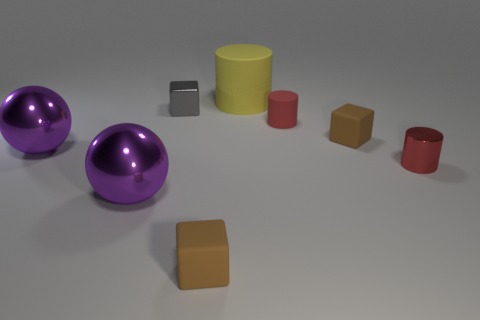Subtract all tiny matte cubes. How many cubes are left? 1 Add 1 small brown blocks. How many objects exist? 9 Subtract all cubes. How many objects are left? 5 Subtract 1 brown cubes. How many objects are left? 7 Subtract all red rubber cylinders. Subtract all tiny objects. How many objects are left? 2 Add 3 small gray objects. How many small gray objects are left? 4 Add 2 red rubber things. How many red rubber things exist? 3 